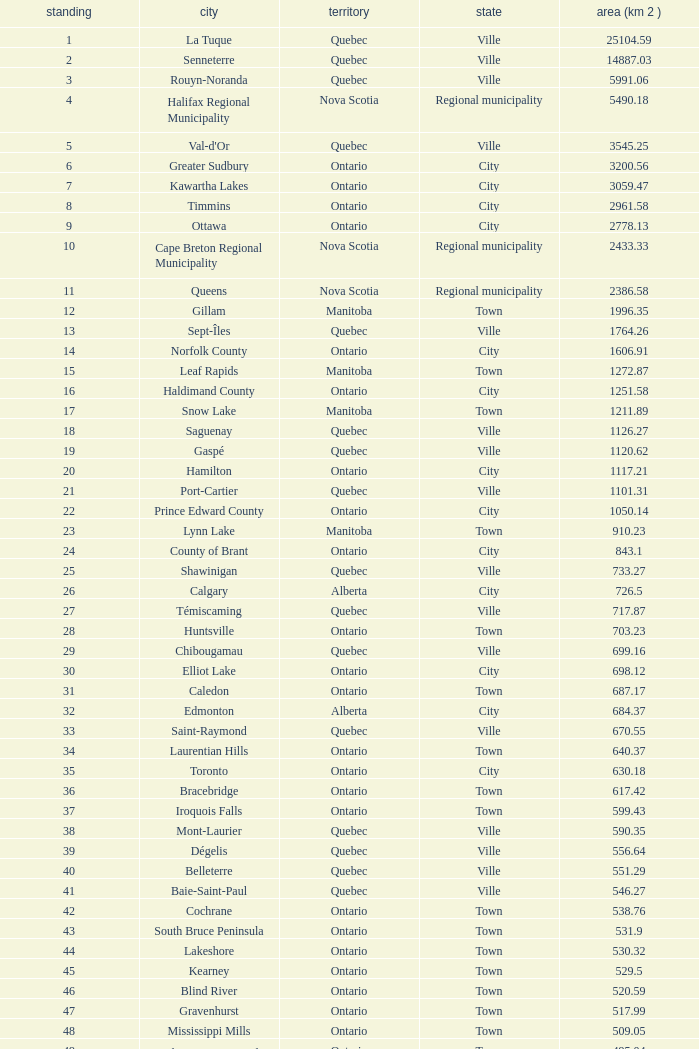What's the total of Rank that has an Area (KM 2) of 1050.14? 22.0. 